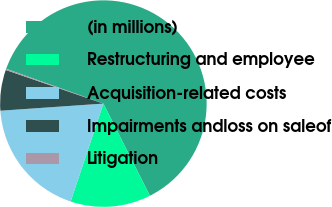Convert chart. <chart><loc_0><loc_0><loc_500><loc_500><pie_chart><fcel>(in millions)<fcel>Restructuring and employee<fcel>Acquisition-related costs<fcel>Impairments andloss on saleof<fcel>Litigation<nl><fcel>62.09%<fcel>12.57%<fcel>18.76%<fcel>6.38%<fcel>0.19%<nl></chart> 